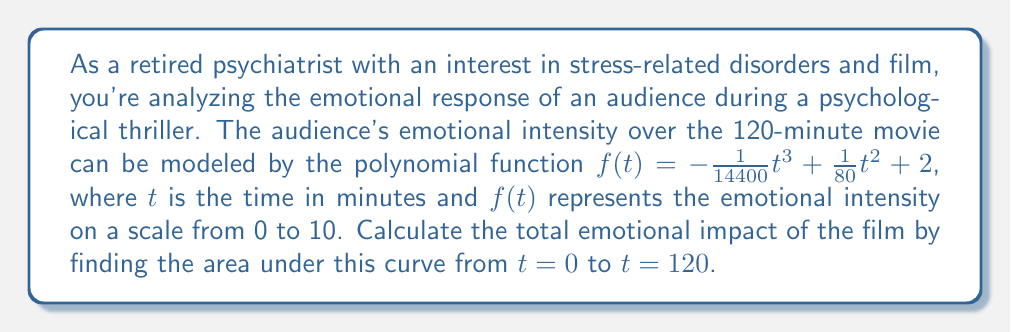Help me with this question. To find the area under the curve, we need to integrate the function $f(t)$ from 0 to 120. Let's approach this step-by-step:

1) The function is $f(t) = -\frac{1}{14400}t^3 + \frac{1}{80}t^2 + 2$

2) To find the area, we integrate:

   $$\int_0^{120} f(t) dt = \int_0^{120} (-\frac{1}{14400}t^3 + \frac{1}{80}t^2 + 2) dt$$

3) Integrate each term:
   
   $$\int_0^{120} (-\frac{1}{14400}t^3) dt = -\frac{1}{14400} \cdot \frac{t^4}{4}$$
   $$\int_0^{120} (\frac{1}{80}t^2) dt = \frac{1}{80} \cdot \frac{t^3}{3}$$
   $$\int_0^{120} 2 dt = 2t$$

4) Combining these:

   $$\int_0^{120} f(t) dt = [-\frac{1}{57600}t^4 + \frac{1}{240}t^3 + 2t]_0^{120}$$

5) Evaluate at the limits:

   $$= (-\frac{1}{57600}(120)^4 + \frac{1}{240}(120)^3 + 2(120)) - (-\frac{1}{57600}(0)^4 + \frac{1}{240}(0)^3 + 2(0))$$

6) Simplify:

   $$= (-6000 + 7200 + 240) - 0 = 1440$$

The total area under the curve represents the cumulative emotional impact over the entire movie.
Answer: The total emotional impact of the film, represented by the area under the curve from $t=0$ to $t=120$, is 1440 emotional intensity-minutes. 